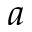<formula> <loc_0><loc_0><loc_500><loc_500>a</formula> 